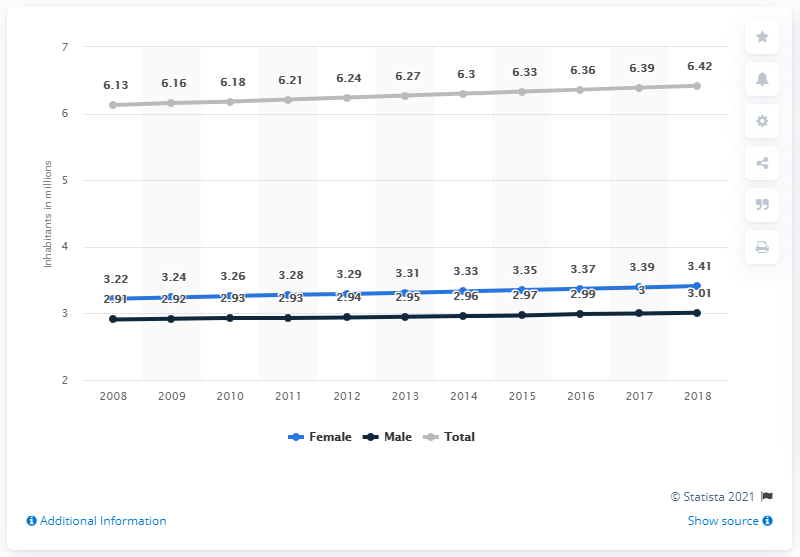Can you explain the trend in the growth rate of the male population over the period shown? Over the period from 2008 to 2018, the male population in El Salvador has shown a slight but consistent increase from about 2.91 million to 3.01 million. This trend suggests a steady growth rate, with some annual fluctuations that are not very pronounced. What might be the implications of such trends for policy making in El Salvador? The steady increase in population could have various implications for policy making in El Salvador, including the need for enhanced infrastructure, educational facilities, and healthcare services to accommodate the growing population. It also underscores the importance of sustainable development plans to manage the gradual increase effectively. 